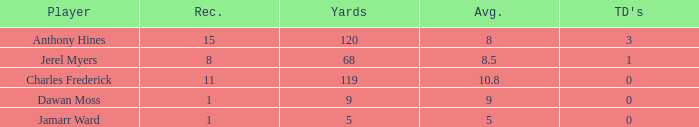What is the total Avg when TDs are 0 and Dawan Moss is a player? 0.0. 